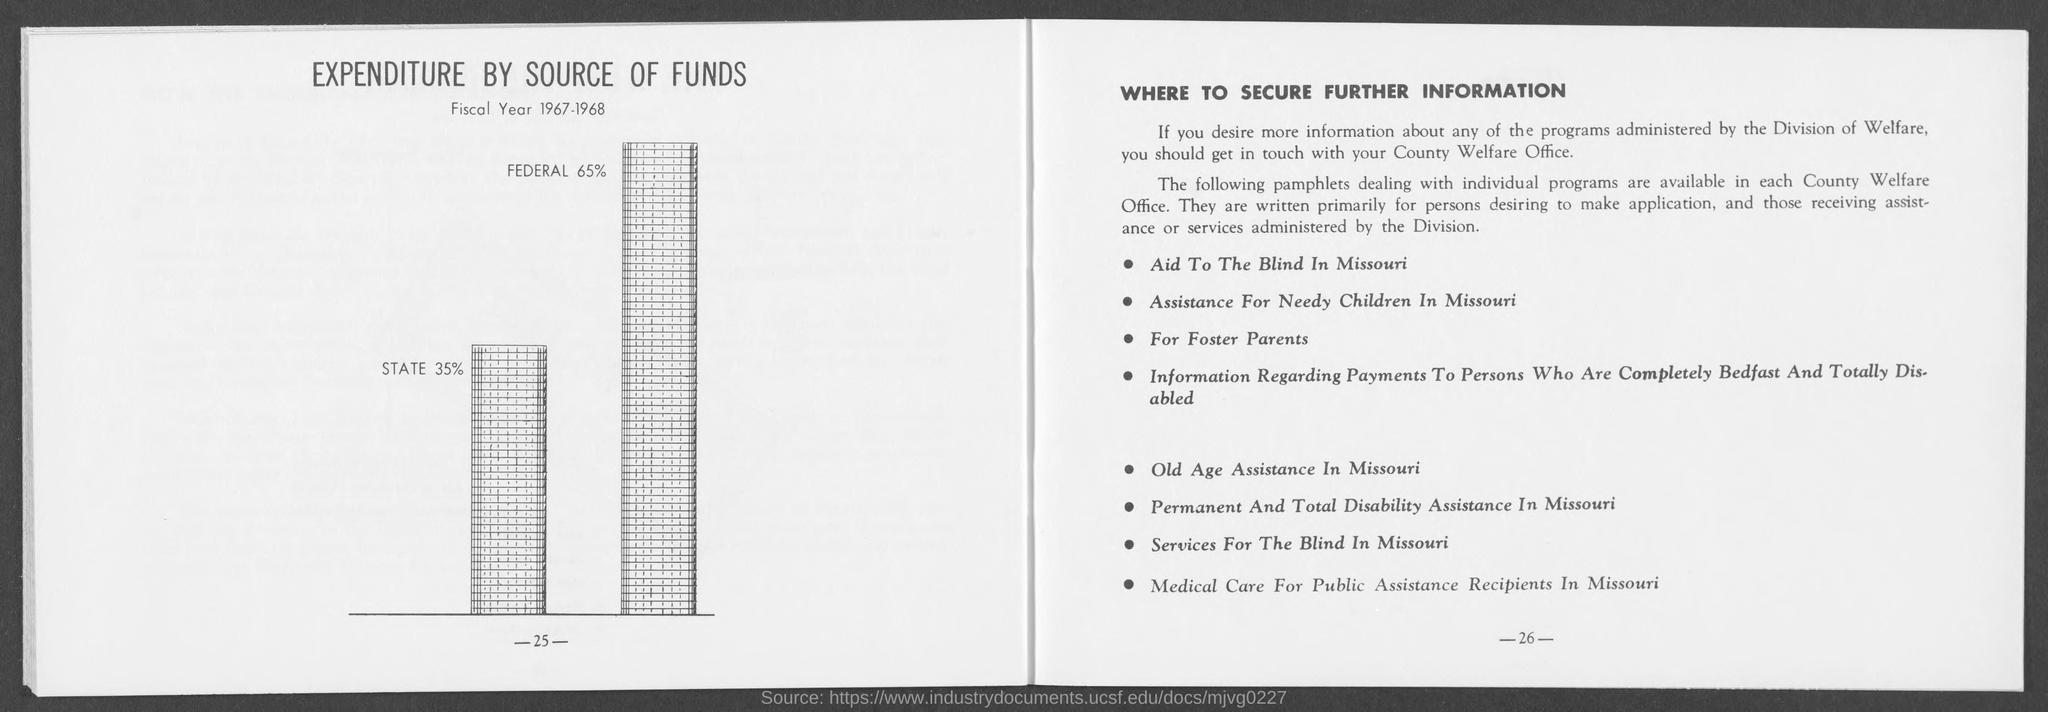Mention a couple of crucial points in this snapshot. According to the information provided on the given page, 35% is the percentage of state. Sixty-five percent of the federal is mentioned in the given page. 